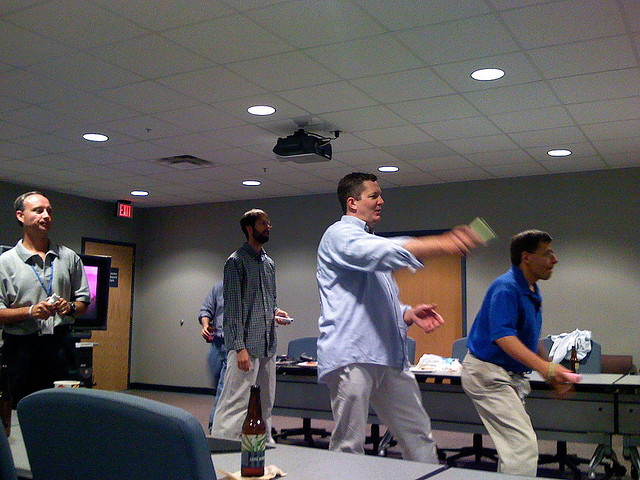Please extract the text content from this image. EXIT 